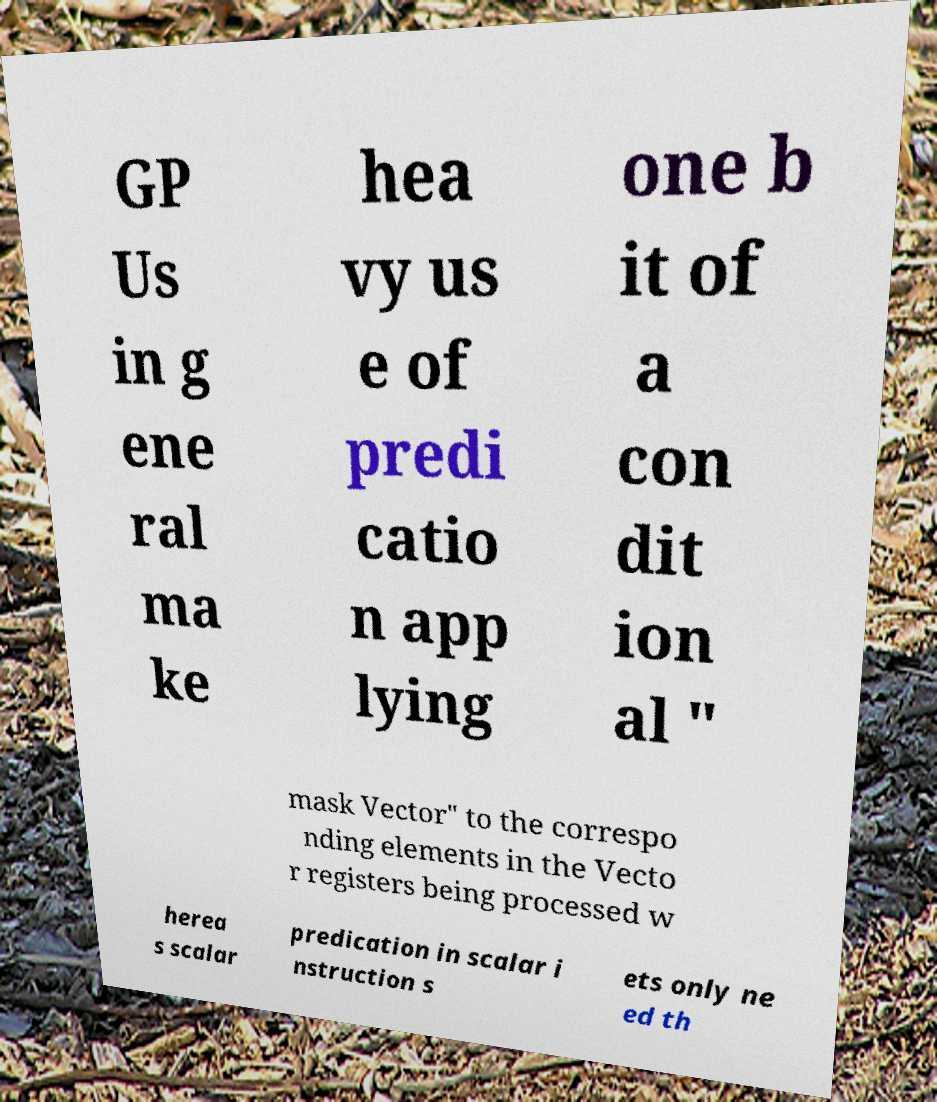Can you accurately transcribe the text from the provided image for me? GP Us in g ene ral ma ke hea vy us e of predi catio n app lying one b it of a con dit ion al " mask Vector" to the correspo nding elements in the Vecto r registers being processed w herea s scalar predication in scalar i nstruction s ets only ne ed th 